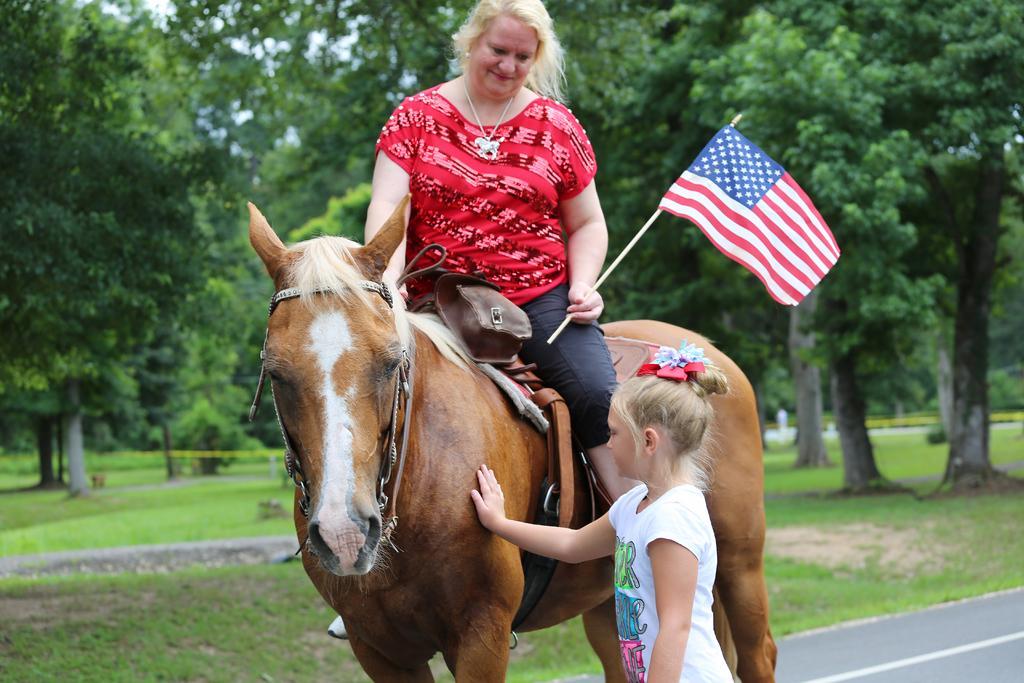How would you summarize this image in a sentence or two? This picture is clicked on a road. There is a woman sitting on a horse. She is wearing red shirt and holding a flag in her hand. Beside the horse there is a girl standing and touching it. In the background there is sky, trees and grass. 